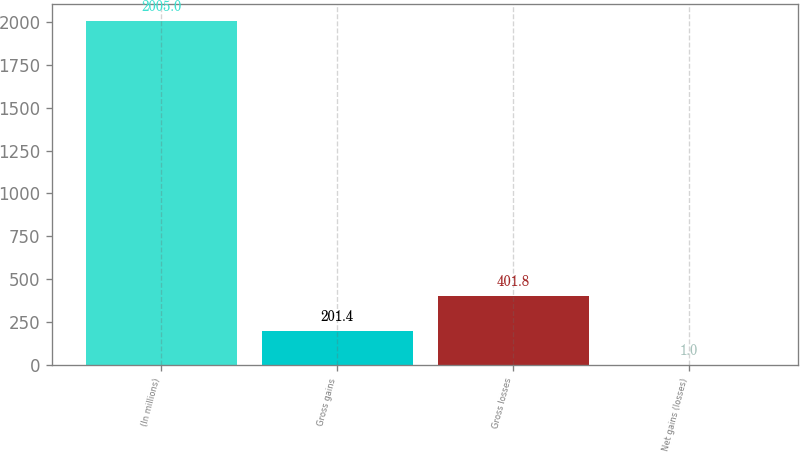Convert chart to OTSL. <chart><loc_0><loc_0><loc_500><loc_500><bar_chart><fcel>(In millions)<fcel>Gross gains<fcel>Gross losses<fcel>Net gains (losses)<nl><fcel>2005<fcel>201.4<fcel>401.8<fcel>1<nl></chart> 